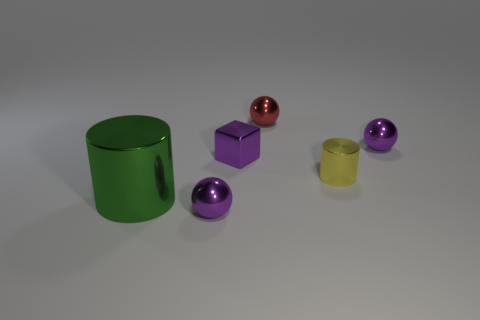What number of things are either tiny shiny things behind the purple metallic block or big purple matte cubes?
Provide a succinct answer. 2. Are there fewer small cyan metallic cylinders than tiny yellow objects?
Provide a short and direct response. Yes. The large thing that is the same material as the small yellow cylinder is what shape?
Give a very brief answer. Cylinder. Are there any green metallic objects behind the green shiny thing?
Your response must be concise. No. Are there fewer metallic blocks that are in front of the tiny yellow object than large red blocks?
Your response must be concise. No. What is the material of the big cylinder?
Your answer should be compact. Metal. What is the color of the big metallic cylinder?
Ensure brevity in your answer.  Green. What color is the metal object that is both to the right of the green object and in front of the tiny yellow object?
Give a very brief answer. Purple. Are there any other things that are made of the same material as the yellow thing?
Your answer should be very brief. Yes. Is the material of the red ball the same as the purple sphere behind the big thing?
Provide a succinct answer. Yes. 